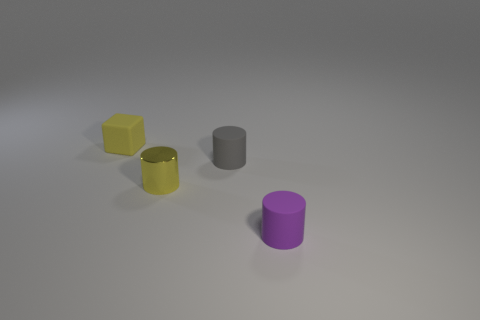There is a yellow object behind the tiny yellow object that is right of the cube; how big is it?
Your response must be concise. Small. Is there a large yellow cube that has the same material as the tiny purple object?
Your response must be concise. No. What is the material of the yellow cylinder that is the same size as the yellow block?
Give a very brief answer. Metal. There is a rubber cylinder in front of the yellow shiny thing; is its color the same as the small cylinder that is behind the tiny yellow cylinder?
Give a very brief answer. No. Is there a tiny purple cylinder behind the tiny matte cylinder that is behind the small purple matte cylinder?
Offer a very short reply. No. Is the shape of the small yellow object that is in front of the yellow matte object the same as the small thing that is in front of the metal cylinder?
Make the answer very short. Yes. Is the yellow thing that is on the right side of the cube made of the same material as the tiny object that is in front of the tiny metallic cylinder?
Provide a succinct answer. No. There is a small yellow thing in front of the matte object to the left of the small yellow cylinder; what is it made of?
Your answer should be compact. Metal. The small yellow object that is in front of the tiny matte thing left of the small cylinder that is to the left of the gray matte cylinder is what shape?
Give a very brief answer. Cylinder. There is a tiny yellow object that is the same shape as the tiny purple rubber object; what is it made of?
Give a very brief answer. Metal. 